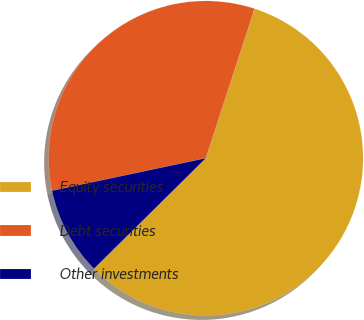Convert chart to OTSL. <chart><loc_0><loc_0><loc_500><loc_500><pie_chart><fcel>Equity securities<fcel>Debt securities<fcel>Other investments<nl><fcel>57.58%<fcel>33.33%<fcel>9.09%<nl></chart> 